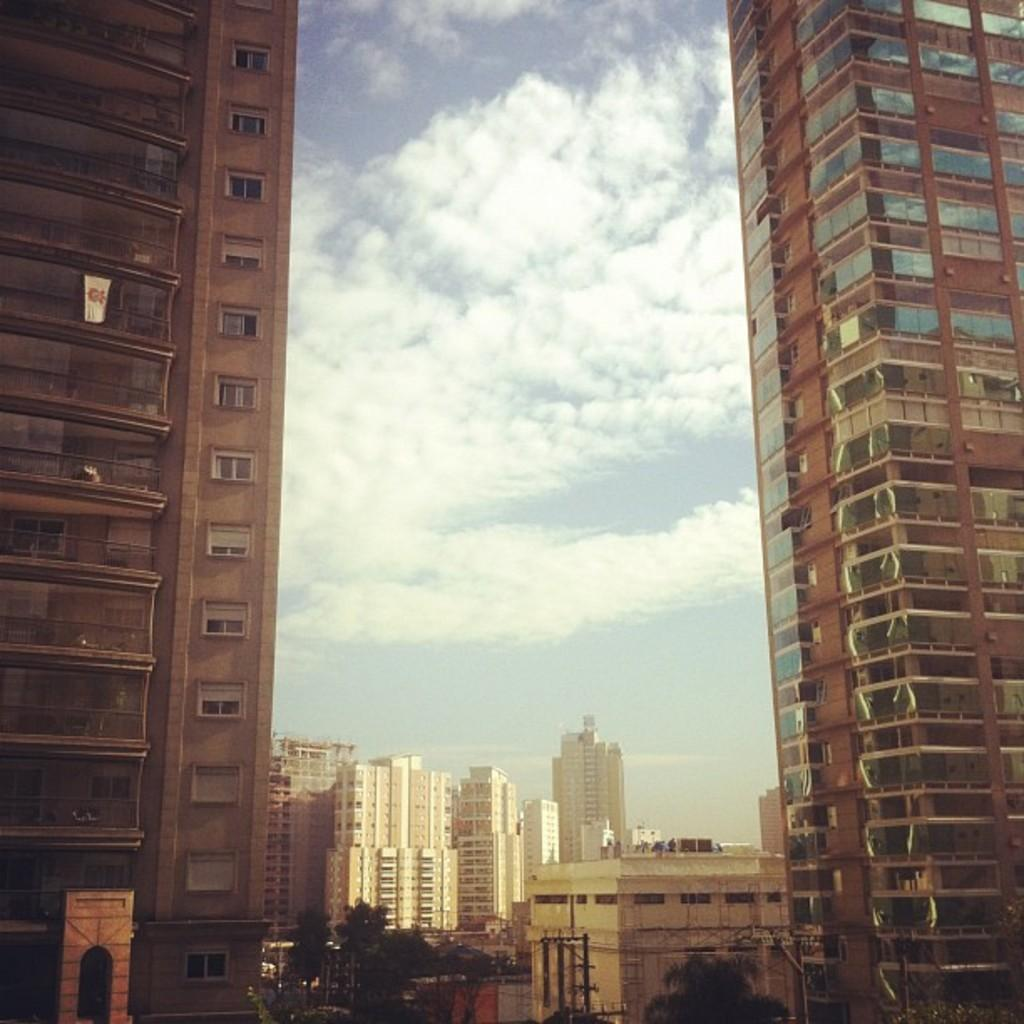What is located on either side of the image? There are buildings on either side of the image. What can be seen in the background of the image? There are many buildings in the background of the image. What type of location does the image depict? The image appears to depict a city. What is visible in the sky in the image? The sky is visible in the image, and clouds are present. What type of soap is being used to clean the buildings in the image? There is no soap or cleaning activity depicted in the image; it simply shows buildings in a city. How does the sand affect the buildings in the image? There is no sand present in the image, so it cannot affect the buildings. 